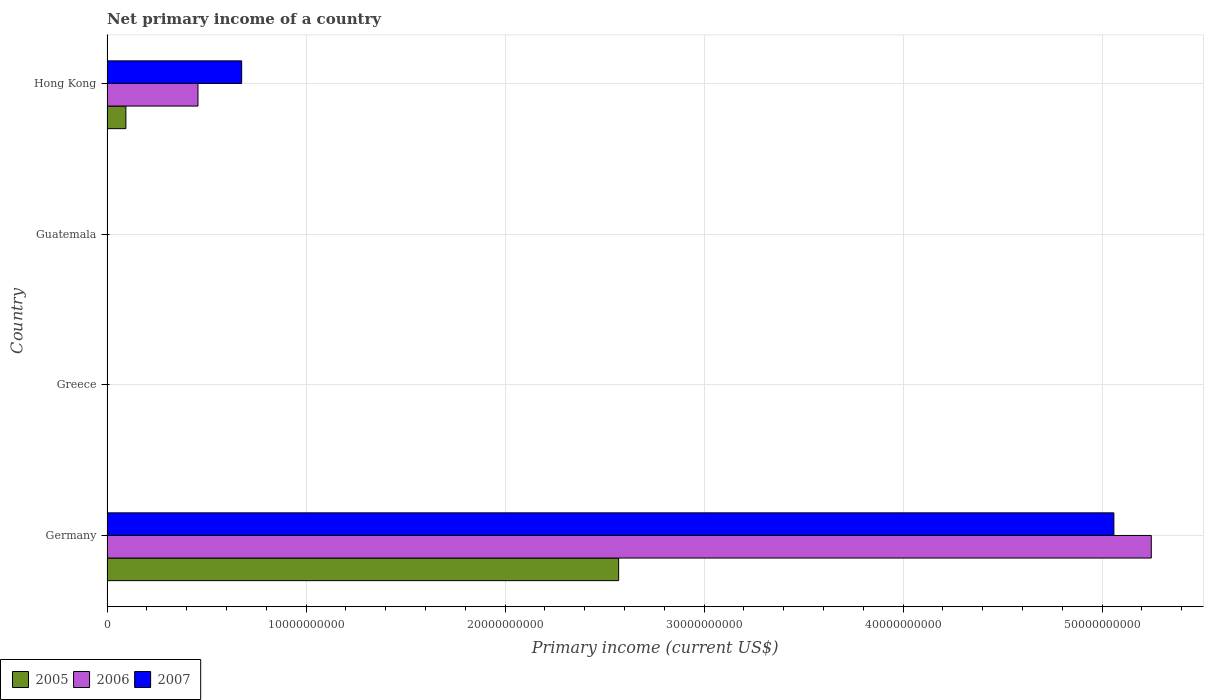Are the number of bars per tick equal to the number of legend labels?
Keep it short and to the point. No. Are the number of bars on each tick of the Y-axis equal?
Give a very brief answer. No. In how many cases, is the number of bars for a given country not equal to the number of legend labels?
Offer a very short reply. 2. Across all countries, what is the maximum primary income in 2005?
Offer a very short reply. 2.57e+1. Across all countries, what is the minimum primary income in 2007?
Provide a short and direct response. 0. What is the total primary income in 2006 in the graph?
Keep it short and to the point. 5.70e+1. What is the difference between the primary income in 2007 in Germany and that in Hong Kong?
Your response must be concise. 4.38e+1. What is the difference between the primary income in 2007 in Greece and the primary income in 2006 in Hong Kong?
Your response must be concise. -4.57e+09. What is the average primary income in 2005 per country?
Make the answer very short. 6.66e+09. What is the difference between the primary income in 2005 and primary income in 2007 in Germany?
Offer a terse response. -2.49e+1. Is the primary income in 2007 in Germany less than that in Hong Kong?
Keep it short and to the point. No. What is the difference between the highest and the lowest primary income in 2006?
Provide a short and direct response. 5.25e+1. How many bars are there?
Offer a terse response. 6. How many countries are there in the graph?
Make the answer very short. 4. What is the difference between two consecutive major ticks on the X-axis?
Offer a terse response. 1.00e+1. Are the values on the major ticks of X-axis written in scientific E-notation?
Your answer should be compact. No. Does the graph contain any zero values?
Provide a short and direct response. Yes. How many legend labels are there?
Your response must be concise. 3. What is the title of the graph?
Keep it short and to the point. Net primary income of a country. What is the label or title of the X-axis?
Provide a succinct answer. Primary income (current US$). What is the label or title of the Y-axis?
Make the answer very short. Country. What is the Primary income (current US$) in 2005 in Germany?
Your response must be concise. 2.57e+1. What is the Primary income (current US$) of 2006 in Germany?
Your response must be concise. 5.25e+1. What is the Primary income (current US$) in 2007 in Germany?
Your answer should be very brief. 5.06e+1. What is the Primary income (current US$) in 2005 in Greece?
Offer a terse response. 0. What is the Primary income (current US$) in 2006 in Greece?
Provide a succinct answer. 0. What is the Primary income (current US$) in 2007 in Greece?
Make the answer very short. 0. What is the Primary income (current US$) in 2005 in Hong Kong?
Make the answer very short. 9.49e+08. What is the Primary income (current US$) of 2006 in Hong Kong?
Ensure brevity in your answer.  4.57e+09. What is the Primary income (current US$) of 2007 in Hong Kong?
Provide a succinct answer. 6.77e+09. Across all countries, what is the maximum Primary income (current US$) in 2005?
Keep it short and to the point. 2.57e+1. Across all countries, what is the maximum Primary income (current US$) of 2006?
Your answer should be very brief. 5.25e+1. Across all countries, what is the maximum Primary income (current US$) in 2007?
Your answer should be compact. 5.06e+1. Across all countries, what is the minimum Primary income (current US$) in 2005?
Offer a very short reply. 0. What is the total Primary income (current US$) in 2005 in the graph?
Your answer should be compact. 2.67e+1. What is the total Primary income (current US$) in 2006 in the graph?
Provide a succinct answer. 5.70e+1. What is the total Primary income (current US$) of 2007 in the graph?
Keep it short and to the point. 5.74e+1. What is the difference between the Primary income (current US$) in 2005 in Germany and that in Hong Kong?
Provide a short and direct response. 2.48e+1. What is the difference between the Primary income (current US$) of 2006 in Germany and that in Hong Kong?
Your response must be concise. 4.79e+1. What is the difference between the Primary income (current US$) of 2007 in Germany and that in Hong Kong?
Your answer should be compact. 4.38e+1. What is the difference between the Primary income (current US$) of 2005 in Germany and the Primary income (current US$) of 2006 in Hong Kong?
Offer a terse response. 2.11e+1. What is the difference between the Primary income (current US$) in 2005 in Germany and the Primary income (current US$) in 2007 in Hong Kong?
Offer a very short reply. 1.89e+1. What is the difference between the Primary income (current US$) of 2006 in Germany and the Primary income (current US$) of 2007 in Hong Kong?
Offer a very short reply. 4.57e+1. What is the average Primary income (current US$) in 2005 per country?
Offer a terse response. 6.66e+09. What is the average Primary income (current US$) of 2006 per country?
Ensure brevity in your answer.  1.43e+1. What is the average Primary income (current US$) in 2007 per country?
Your answer should be compact. 1.43e+1. What is the difference between the Primary income (current US$) of 2005 and Primary income (current US$) of 2006 in Germany?
Offer a terse response. -2.68e+1. What is the difference between the Primary income (current US$) of 2005 and Primary income (current US$) of 2007 in Germany?
Your response must be concise. -2.49e+1. What is the difference between the Primary income (current US$) of 2006 and Primary income (current US$) of 2007 in Germany?
Your answer should be very brief. 1.88e+09. What is the difference between the Primary income (current US$) in 2005 and Primary income (current US$) in 2006 in Hong Kong?
Ensure brevity in your answer.  -3.62e+09. What is the difference between the Primary income (current US$) in 2005 and Primary income (current US$) in 2007 in Hong Kong?
Ensure brevity in your answer.  -5.82e+09. What is the difference between the Primary income (current US$) in 2006 and Primary income (current US$) in 2007 in Hong Kong?
Keep it short and to the point. -2.20e+09. What is the ratio of the Primary income (current US$) in 2005 in Germany to that in Hong Kong?
Your response must be concise. 27.09. What is the ratio of the Primary income (current US$) in 2006 in Germany to that in Hong Kong?
Give a very brief answer. 11.48. What is the ratio of the Primary income (current US$) in 2007 in Germany to that in Hong Kong?
Keep it short and to the point. 7.48. What is the difference between the highest and the lowest Primary income (current US$) in 2005?
Ensure brevity in your answer.  2.57e+1. What is the difference between the highest and the lowest Primary income (current US$) in 2006?
Your answer should be compact. 5.25e+1. What is the difference between the highest and the lowest Primary income (current US$) of 2007?
Offer a terse response. 5.06e+1. 